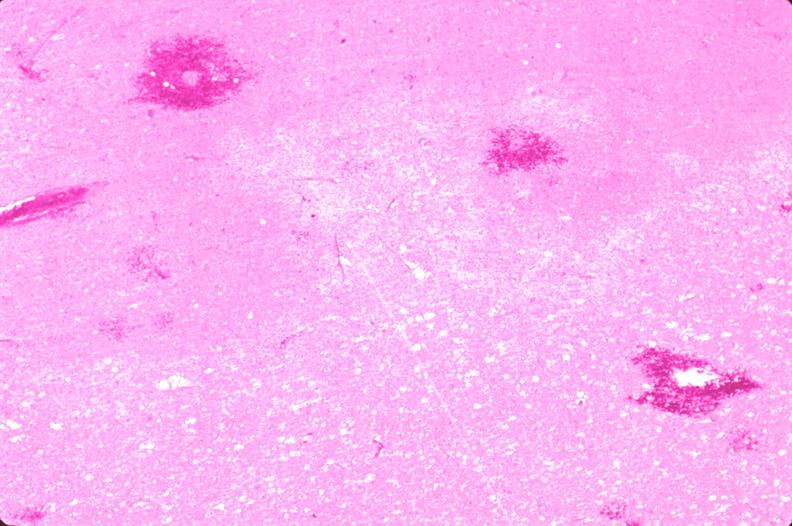s nervous present?
Answer the question using a single word or phrase. Yes 